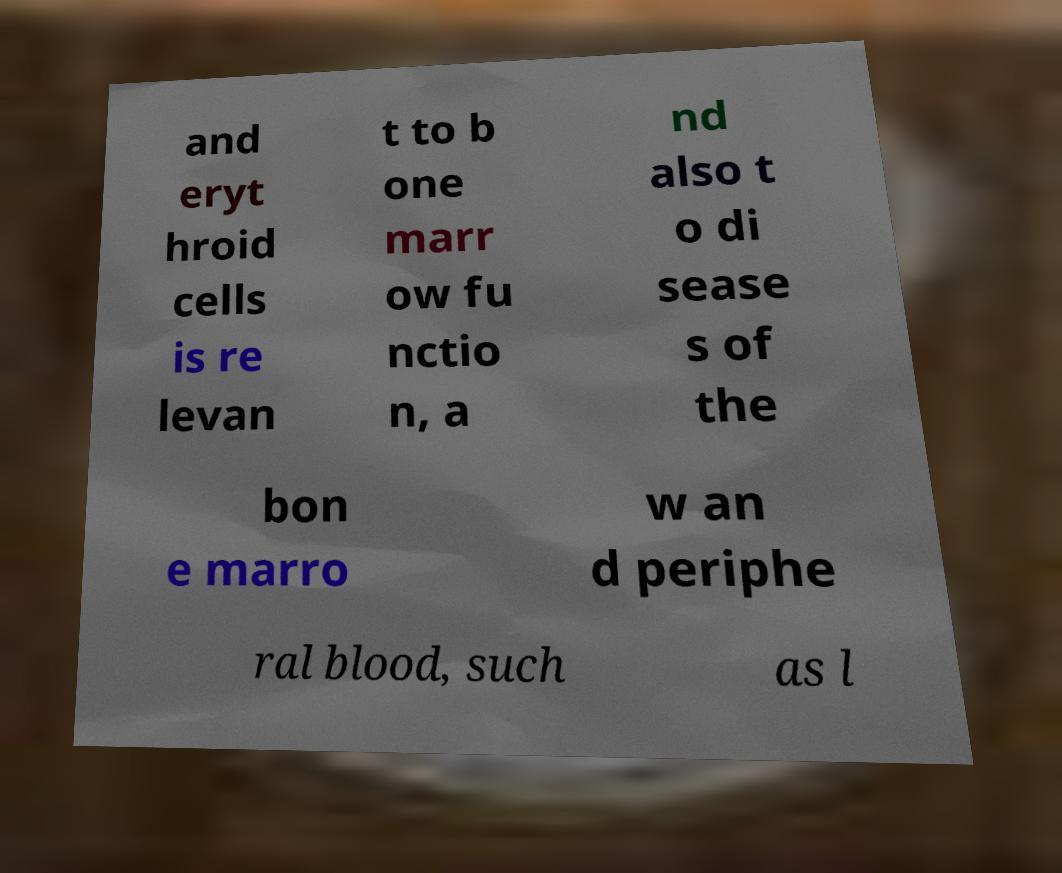For documentation purposes, I need the text within this image transcribed. Could you provide that? and eryt hroid cells is re levan t to b one marr ow fu nctio n, a nd also t o di sease s of the bon e marro w an d periphe ral blood, such as l 